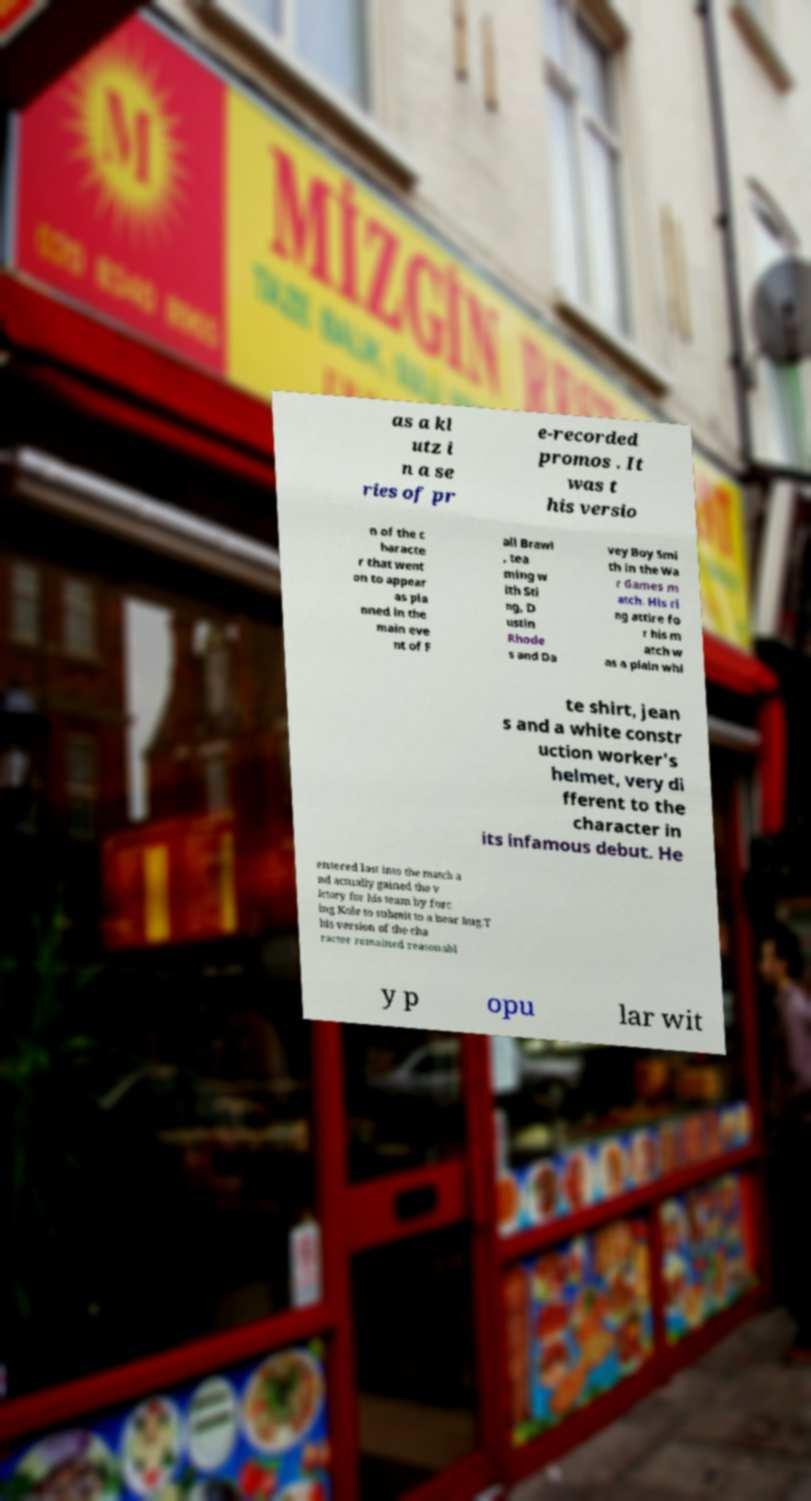I need the written content from this picture converted into text. Can you do that? as a kl utz i n a se ries of pr e-recorded promos . It was t his versio n of the c haracte r that went on to appear as pla nned in the main eve nt of F all Brawl , tea ming w ith Sti ng, D ustin Rhode s and Da vey Boy Smi th in the Wa r Games m atch. His ri ng attire fo r his m atch w as a plain whi te shirt, jean s and a white constr uction worker's helmet, very di fferent to the character in its infamous debut. He entered last into the match a nd actually gained the v ictory for his team by forc ing Kole to submit to a bear hug.T his version of the cha racter remained reasonabl y p opu lar wit 